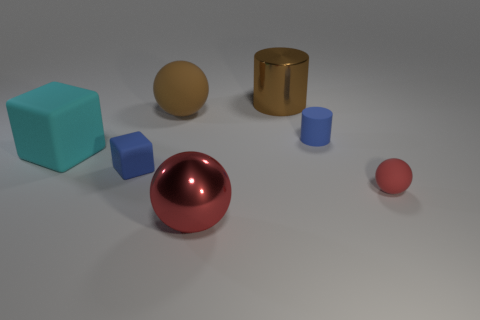Subtract all large balls. How many balls are left? 1 Subtract all brown balls. How many balls are left? 2 Add 2 small blue cylinders. How many objects exist? 9 Subtract all spheres. How many objects are left? 4 Add 5 big brown matte balls. How many big brown matte balls are left? 6 Add 2 yellow spheres. How many yellow spheres exist? 2 Subtract 0 gray cylinders. How many objects are left? 7 Subtract 1 cylinders. How many cylinders are left? 1 Subtract all cyan cubes. Subtract all gray cylinders. How many cubes are left? 1 Subtract all green spheres. How many red cubes are left? 0 